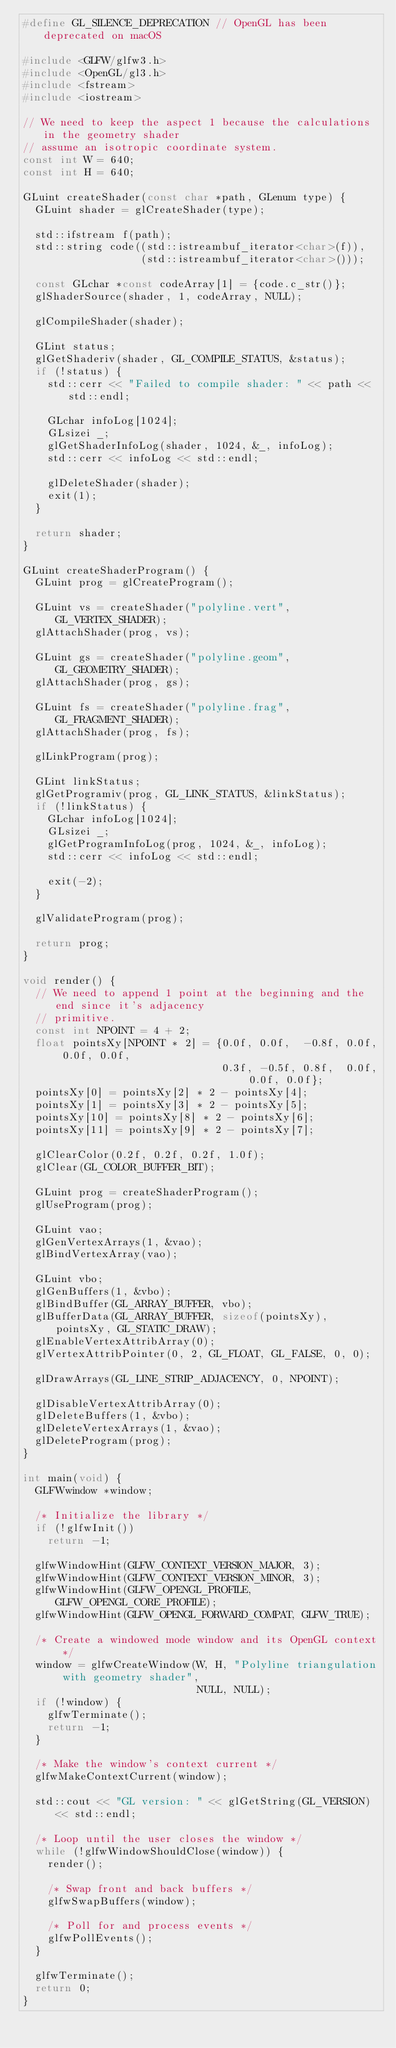<code> <loc_0><loc_0><loc_500><loc_500><_C++_>#define GL_SILENCE_DEPRECATION // OpenGL has been deprecated on macOS

#include <GLFW/glfw3.h>
#include <OpenGL/gl3.h>
#include <fstream>
#include <iostream>

// We need to keep the aspect 1 because the calculations in the geometry shader
// assume an isotropic coordinate system.
const int W = 640;
const int H = 640;

GLuint createShader(const char *path, GLenum type) {
  GLuint shader = glCreateShader(type);

  std::ifstream f(path);
  std::string code((std::istreambuf_iterator<char>(f)),
                   (std::istreambuf_iterator<char>()));

  const GLchar *const codeArray[1] = {code.c_str()};
  glShaderSource(shader, 1, codeArray, NULL);

  glCompileShader(shader);

  GLint status;
  glGetShaderiv(shader, GL_COMPILE_STATUS, &status);
  if (!status) {
    std::cerr << "Failed to compile shader: " << path << std::endl;

    GLchar infoLog[1024];
    GLsizei _;
    glGetShaderInfoLog(shader, 1024, &_, infoLog);
    std::cerr << infoLog << std::endl;

    glDeleteShader(shader);
    exit(1);
  }

  return shader;
}

GLuint createShaderProgram() {
  GLuint prog = glCreateProgram();

  GLuint vs = createShader("polyline.vert", GL_VERTEX_SHADER);
  glAttachShader(prog, vs);

  GLuint gs = createShader("polyline.geom", GL_GEOMETRY_SHADER);
  glAttachShader(prog, gs);

  GLuint fs = createShader("polyline.frag", GL_FRAGMENT_SHADER);
  glAttachShader(prog, fs);

  glLinkProgram(prog);

  GLint linkStatus;
  glGetProgramiv(prog, GL_LINK_STATUS, &linkStatus);
  if (!linkStatus) {
    GLchar infoLog[1024];
    GLsizei _;
    glGetProgramInfoLog(prog, 1024, &_, infoLog);
    std::cerr << infoLog << std::endl;

    exit(-2);
  }

  glValidateProgram(prog);

  return prog;
}

void render() {
  // We need to append 1 point at the beginning and the end since it's adjacency
  // primitive.
  const int NPOINT = 4 + 2;
  float pointsXy[NPOINT * 2] = {0.0f, 0.0f,  -0.8f, 0.0f, 0.0f, 0.0f,
                                0.3f, -0.5f, 0.8f,  0.0f, 0.0f, 0.0f};
  pointsXy[0] = pointsXy[2] * 2 - pointsXy[4];
  pointsXy[1] = pointsXy[3] * 2 - pointsXy[5];
  pointsXy[10] = pointsXy[8] * 2 - pointsXy[6];
  pointsXy[11] = pointsXy[9] * 2 - pointsXy[7];

  glClearColor(0.2f, 0.2f, 0.2f, 1.0f);
  glClear(GL_COLOR_BUFFER_BIT);

  GLuint prog = createShaderProgram();
  glUseProgram(prog);

  GLuint vao;
  glGenVertexArrays(1, &vao);
  glBindVertexArray(vao);

  GLuint vbo;
  glGenBuffers(1, &vbo);
  glBindBuffer(GL_ARRAY_BUFFER, vbo);
  glBufferData(GL_ARRAY_BUFFER, sizeof(pointsXy), pointsXy, GL_STATIC_DRAW);
  glEnableVertexAttribArray(0);
  glVertexAttribPointer(0, 2, GL_FLOAT, GL_FALSE, 0, 0);

  glDrawArrays(GL_LINE_STRIP_ADJACENCY, 0, NPOINT);

  glDisableVertexAttribArray(0);
  glDeleteBuffers(1, &vbo);
  glDeleteVertexArrays(1, &vao);
  glDeleteProgram(prog);
}

int main(void) {
  GLFWwindow *window;

  /* Initialize the library */
  if (!glfwInit())
    return -1;

  glfwWindowHint(GLFW_CONTEXT_VERSION_MAJOR, 3);
  glfwWindowHint(GLFW_CONTEXT_VERSION_MINOR, 3);
  glfwWindowHint(GLFW_OPENGL_PROFILE, GLFW_OPENGL_CORE_PROFILE);
  glfwWindowHint(GLFW_OPENGL_FORWARD_COMPAT, GLFW_TRUE);

  /* Create a windowed mode window and its OpenGL context */
  window = glfwCreateWindow(W, H, "Polyline triangulation with geometry shader",
                            NULL, NULL);
  if (!window) {
    glfwTerminate();
    return -1;
  }

  /* Make the window's context current */
  glfwMakeContextCurrent(window);

  std::cout << "GL version: " << glGetString(GL_VERSION) << std::endl;

  /* Loop until the user closes the window */
  while (!glfwWindowShouldClose(window)) {
    render();

    /* Swap front and back buffers */
    glfwSwapBuffers(window);

    /* Poll for and process events */
    glfwPollEvents();
  }

  glfwTerminate();
  return 0;
}
</code> 